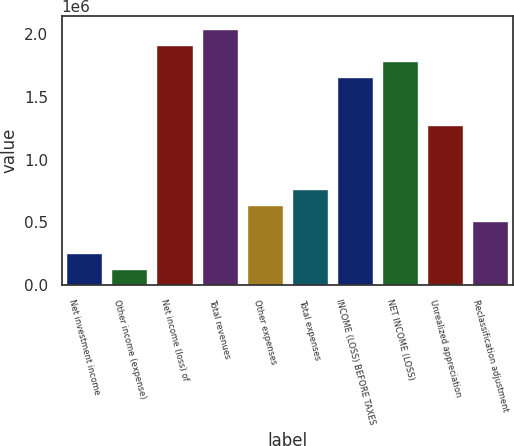Convert chart to OTSL. <chart><loc_0><loc_0><loc_500><loc_500><bar_chart><fcel>Net investment income<fcel>Other income (expense)<fcel>Net income (loss) of<fcel>Total revenues<fcel>Other expenses<fcel>Total expenses<fcel>INCOME (LOSS) BEFORE TAXES<fcel>NET INCOME (LOSS)<fcel>Unrealized appreciation<fcel>Reclassification adjustment<nl><fcel>255337<fcel>127749<fcel>1.91397e+06<fcel>2.04156e+06<fcel>638098<fcel>765686<fcel>1.6588e+06<fcel>1.78638e+06<fcel>1.27604e+06<fcel>510511<nl></chart> 